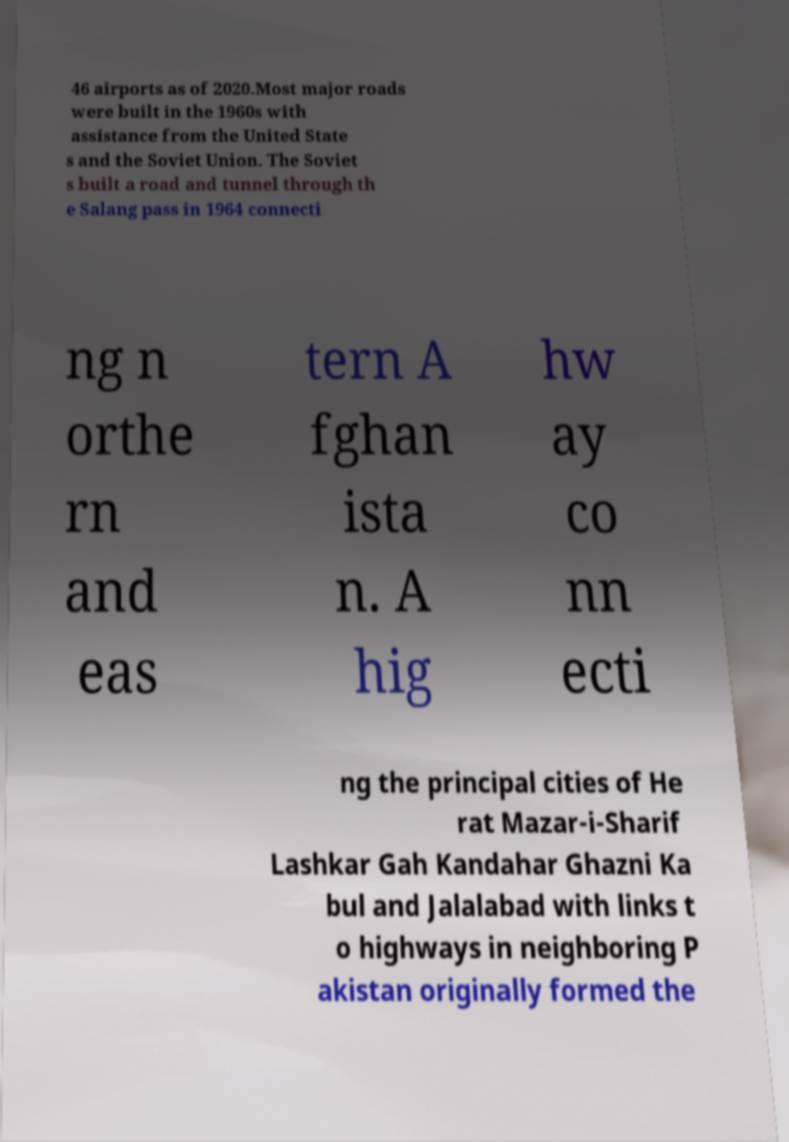Could you extract and type out the text from this image? 46 airports as of 2020.Most major roads were built in the 1960s with assistance from the United State s and the Soviet Union. The Soviet s built a road and tunnel through th e Salang pass in 1964 connecti ng n orthe rn and eas tern A fghan ista n. A hig hw ay co nn ecti ng the principal cities of He rat Mazar-i-Sharif Lashkar Gah Kandahar Ghazni Ka bul and Jalalabad with links t o highways in neighboring P akistan originally formed the 